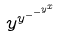<formula> <loc_0><loc_0><loc_500><loc_500>y ^ { y ^ { - ^ { - ^ { y ^ { x } } } } }</formula> 